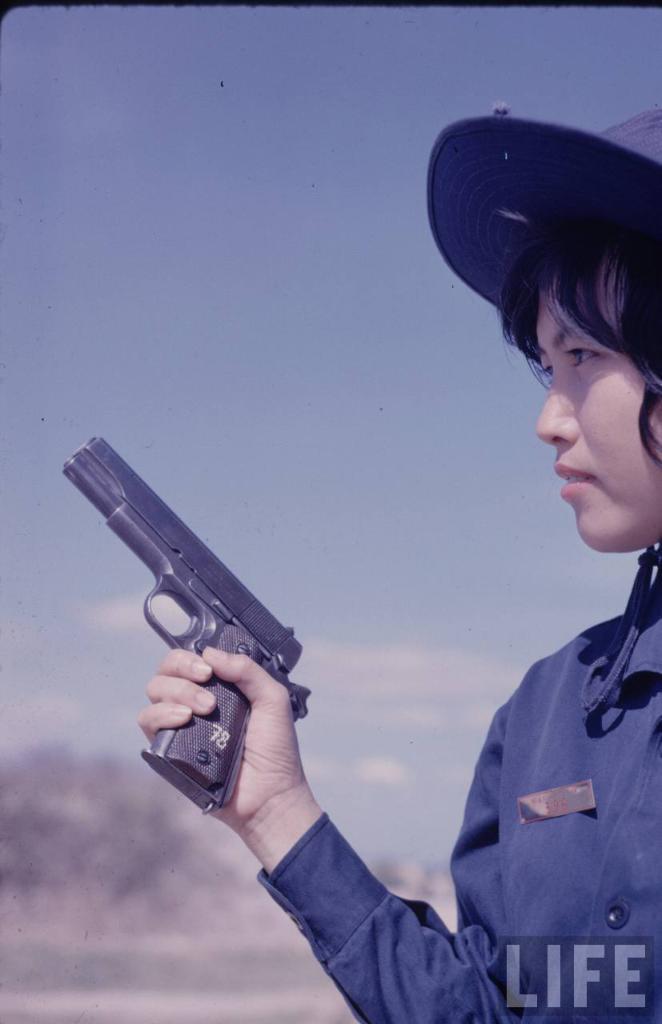What is the person in the image holding? The person in the image is holding a gun. What can be seen in the background of the image? There are trees and sky visible in the background of the image. Is there any text present in the image? Yes, there is some text at the bottom of the image. What type of quiver is the person using to hold the arrows in the image? There are no arrows or quiver present in the image; the person is holding a gun. 